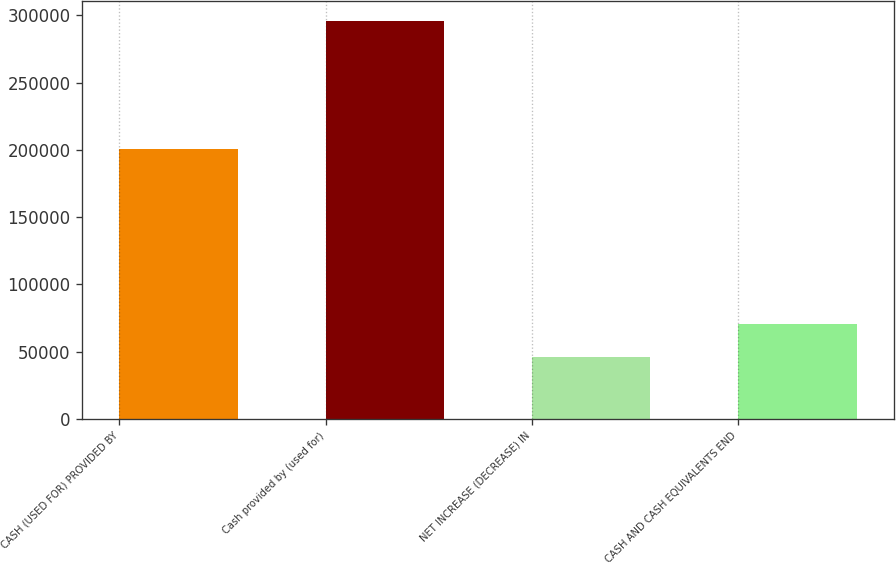Convert chart to OTSL. <chart><loc_0><loc_0><loc_500><loc_500><bar_chart><fcel>CASH (USED FOR) PROVIDED BY<fcel>Cash provided by (used for)<fcel>NET INCREASE (DECREASE) IN<fcel>CASH AND CASH EQUIVALENTS END<nl><fcel>200737<fcel>295600<fcel>45791<fcel>70771.9<nl></chart> 